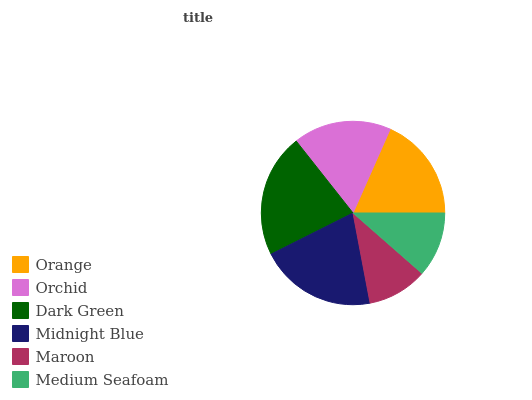Is Maroon the minimum?
Answer yes or no. Yes. Is Dark Green the maximum?
Answer yes or no. Yes. Is Orchid the minimum?
Answer yes or no. No. Is Orchid the maximum?
Answer yes or no. No. Is Orange greater than Orchid?
Answer yes or no. Yes. Is Orchid less than Orange?
Answer yes or no. Yes. Is Orchid greater than Orange?
Answer yes or no. No. Is Orange less than Orchid?
Answer yes or no. No. Is Orange the high median?
Answer yes or no. Yes. Is Orchid the low median?
Answer yes or no. Yes. Is Midnight Blue the high median?
Answer yes or no. No. Is Orange the low median?
Answer yes or no. No. 